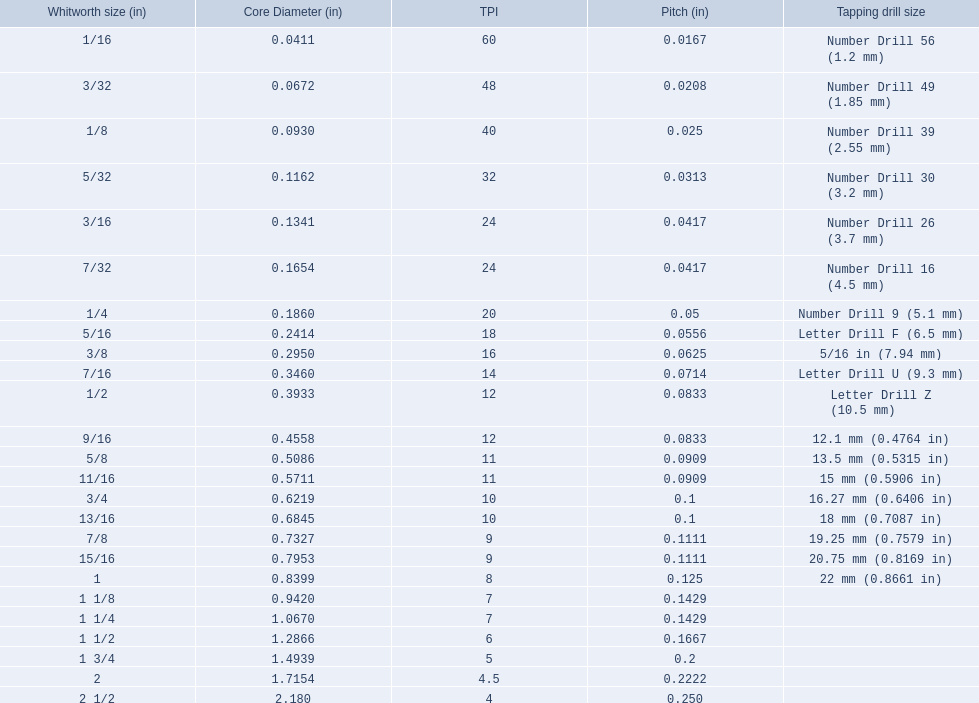What are all of the whitworth sizes in the british standard whitworth? 1/16, 3/32, 1/8, 5/32, 3/16, 7/32, 1/4, 5/16, 3/8, 7/16, 1/2, 9/16, 5/8, 11/16, 3/4, 13/16, 7/8, 15/16, 1, 1 1/8, 1 1/4, 1 1/2, 1 3/4, 2, 2 1/2. Which of these sizes uses a tapping drill size of 26? 3/16. 